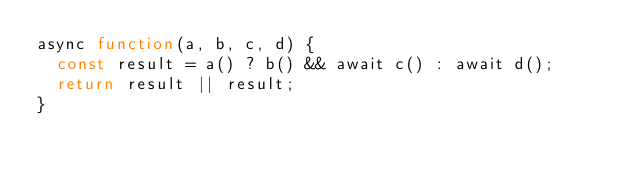<code> <loc_0><loc_0><loc_500><loc_500><_JavaScript_>async function(a, b, c, d) {
	const result = a() ? b() && await c() : await d();
	return result || result;
}
</code> 